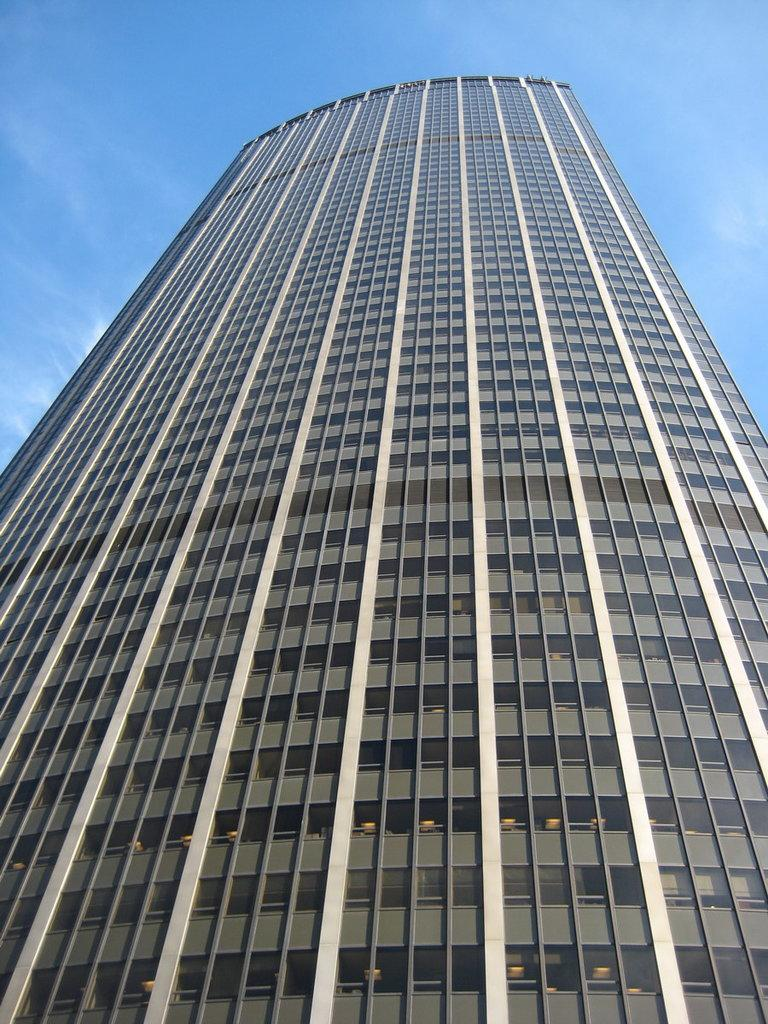What is the main structure visible in the foreground of the image? There is a skyscraper in the foreground of the image. What can be seen in the background of the image? The sky is visible in the background of the image. Where is the plantation located in the image? There is no plantation present in the image. What type of brush is being used to paint the sky in the image? The image is a photograph and not a painting, so there is no brush used to paint the sky. 